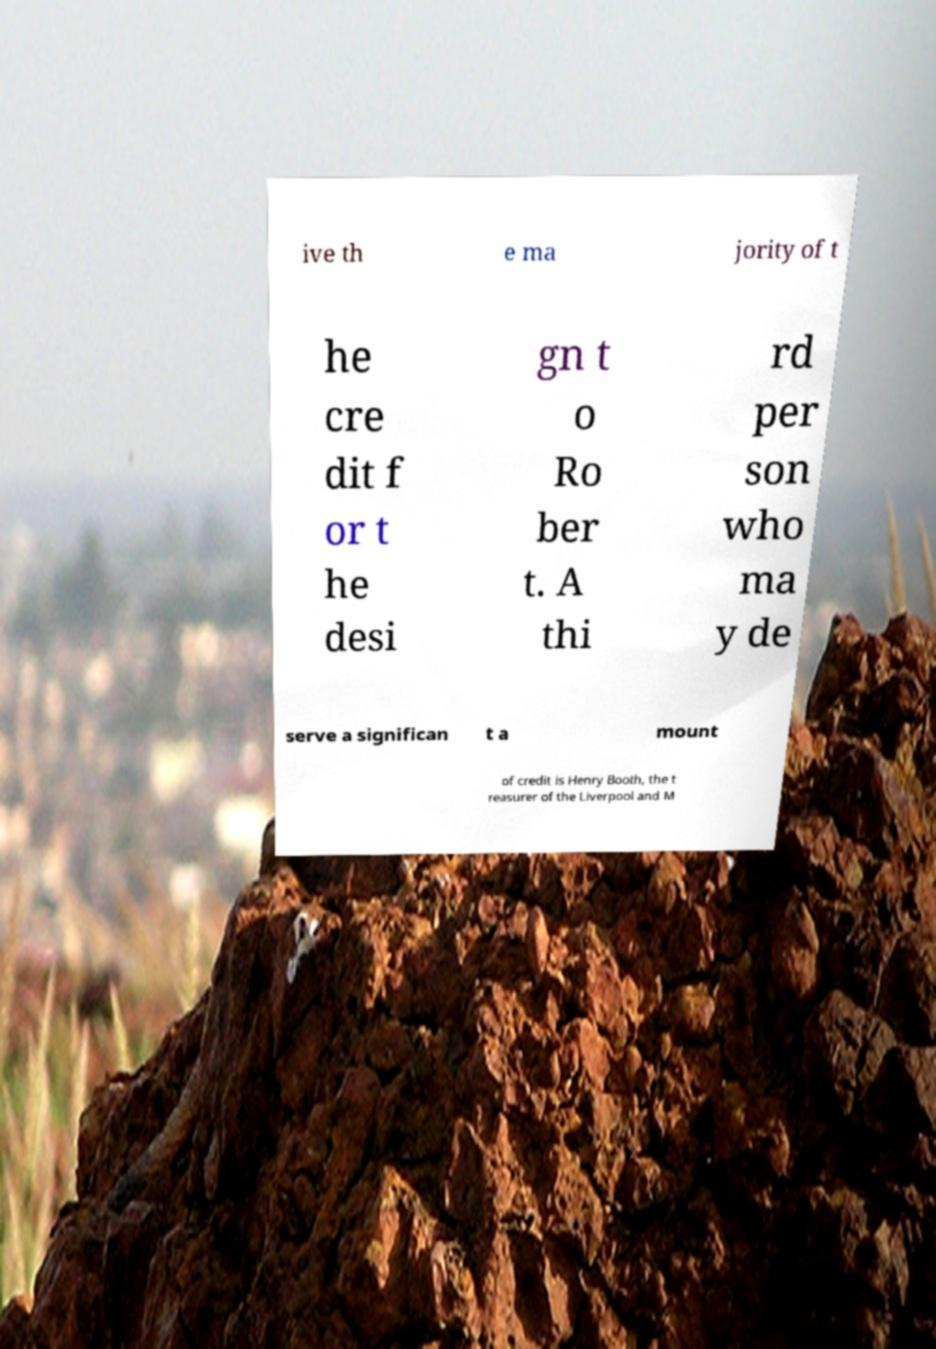I need the written content from this picture converted into text. Can you do that? ive th e ma jority of t he cre dit f or t he desi gn t o Ro ber t. A thi rd per son who ma y de serve a significan t a mount of credit is Henry Booth, the t reasurer of the Liverpool and M 